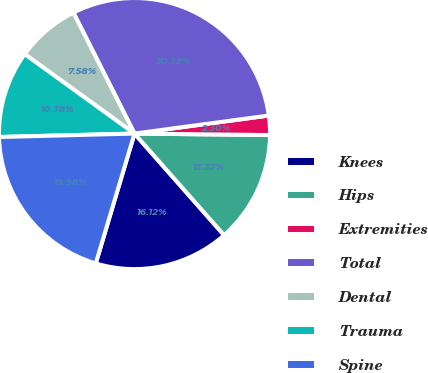<chart> <loc_0><loc_0><loc_500><loc_500><pie_chart><fcel>Knees<fcel>Hips<fcel>Extremities<fcel>Total<fcel>Dental<fcel>Trauma<fcel>Spine<nl><fcel>16.12%<fcel>13.32%<fcel>2.3%<fcel>30.32%<fcel>7.58%<fcel>10.38%<fcel>19.98%<nl></chart> 